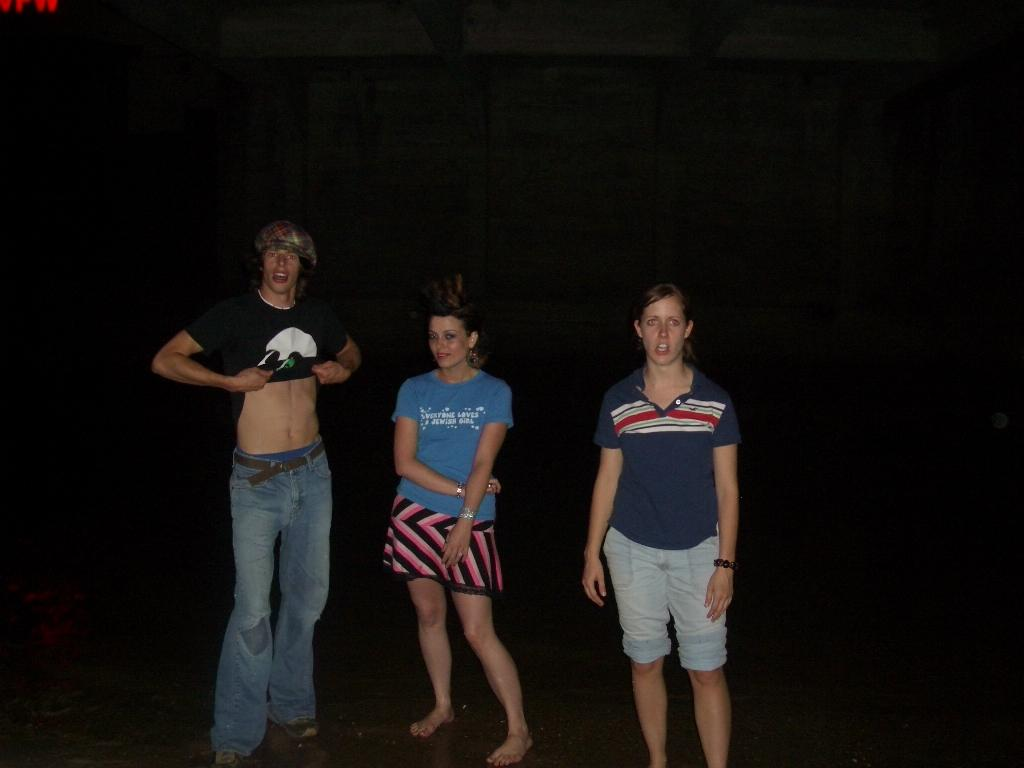Provide a one-sentence caption for the provided image. A man lifts his shirt next to a woman wearing a shirt that says "Everyone loves Jewish girls.". 